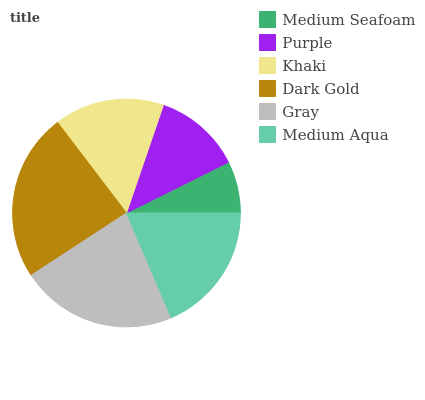Is Medium Seafoam the minimum?
Answer yes or no. Yes. Is Dark Gold the maximum?
Answer yes or no. Yes. Is Purple the minimum?
Answer yes or no. No. Is Purple the maximum?
Answer yes or no. No. Is Purple greater than Medium Seafoam?
Answer yes or no. Yes. Is Medium Seafoam less than Purple?
Answer yes or no. Yes. Is Medium Seafoam greater than Purple?
Answer yes or no. No. Is Purple less than Medium Seafoam?
Answer yes or no. No. Is Medium Aqua the high median?
Answer yes or no. Yes. Is Khaki the low median?
Answer yes or no. Yes. Is Purple the high median?
Answer yes or no. No. Is Dark Gold the low median?
Answer yes or no. No. 